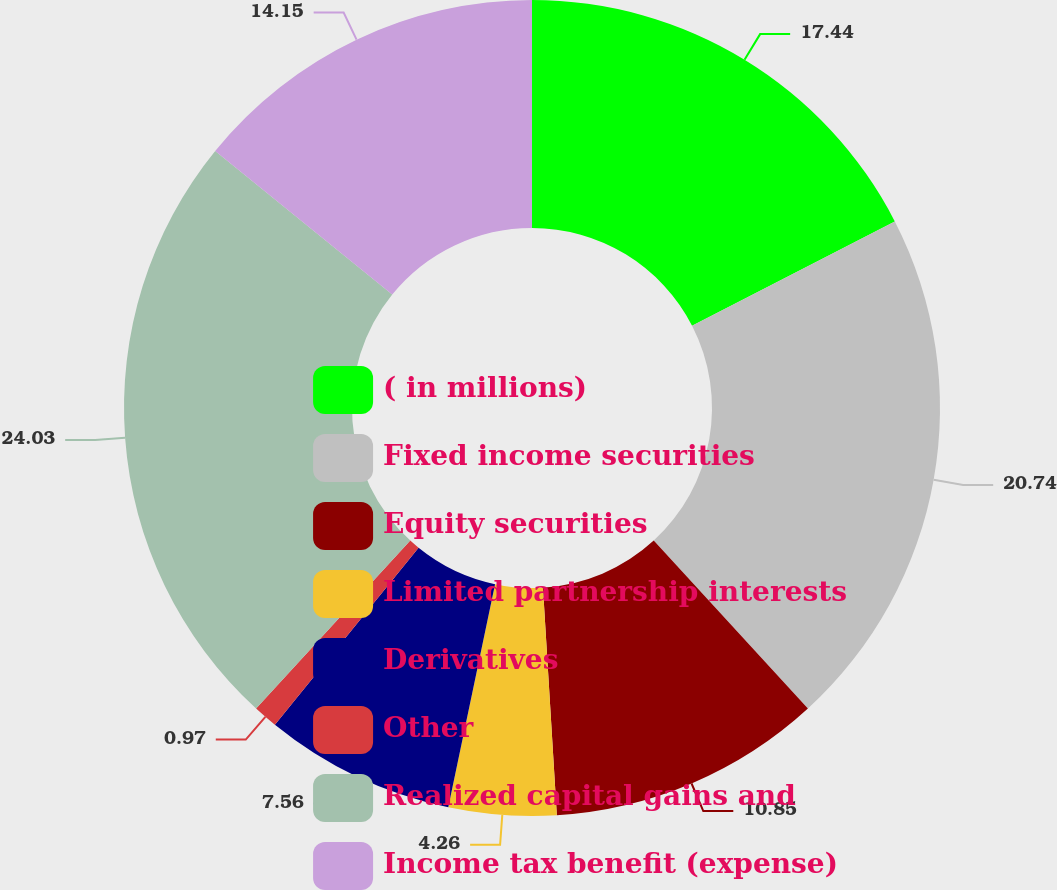Convert chart. <chart><loc_0><loc_0><loc_500><loc_500><pie_chart><fcel>( in millions)<fcel>Fixed income securities<fcel>Equity securities<fcel>Limited partnership interests<fcel>Derivatives<fcel>Other<fcel>Realized capital gains and<fcel>Income tax benefit (expense)<nl><fcel>17.44%<fcel>20.74%<fcel>10.85%<fcel>4.26%<fcel>7.56%<fcel>0.97%<fcel>24.03%<fcel>14.15%<nl></chart> 